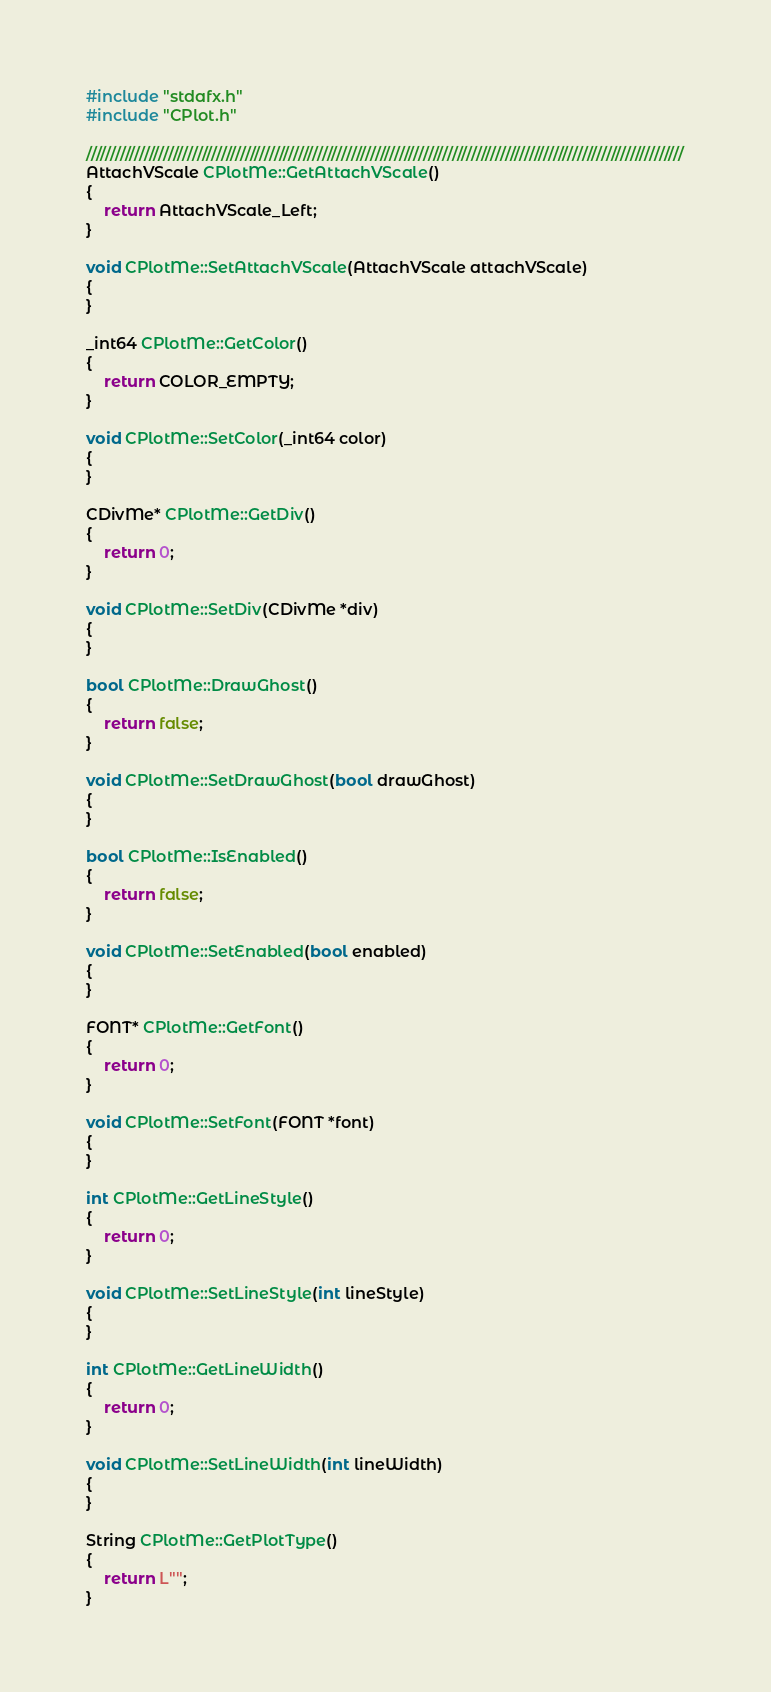<code> <loc_0><loc_0><loc_500><loc_500><_ObjectiveC_>#include "stdafx.h"
#include "CPlot.h"

////////////////////////////////////////////////////////////////////////////////////////////////////////////////////////////
AttachVScale CPlotMe::GetAttachVScale()
{
	return AttachVScale_Left;
}

void CPlotMe::SetAttachVScale(AttachVScale attachVScale)
{
}

_int64 CPlotMe::GetColor()
{
	return COLOR_EMPTY;
}

void CPlotMe::SetColor(_int64 color)
{
}

CDivMe* CPlotMe::GetDiv()
{
	return 0;
}

void CPlotMe::SetDiv(CDivMe *div)
{
}

bool CPlotMe::DrawGhost()
{
	return false;
}

void CPlotMe::SetDrawGhost(bool drawGhost)
{
}

bool CPlotMe::IsEnabled()
{
	return false;
}

void CPlotMe::SetEnabled(bool enabled)
{
}

FONT* CPlotMe::GetFont()
{
	return 0;
}

void CPlotMe::SetFont(FONT *font)
{
}

int CPlotMe::GetLineStyle()
{
	return 0;
}

void CPlotMe::SetLineStyle(int lineStyle)
{
}

int CPlotMe::GetLineWidth()
{
	return 0;
}

void CPlotMe::SetLineWidth(int lineWidth)
{
}

String CPlotMe::GetPlotType()
{
	return L"";
}
</code> 